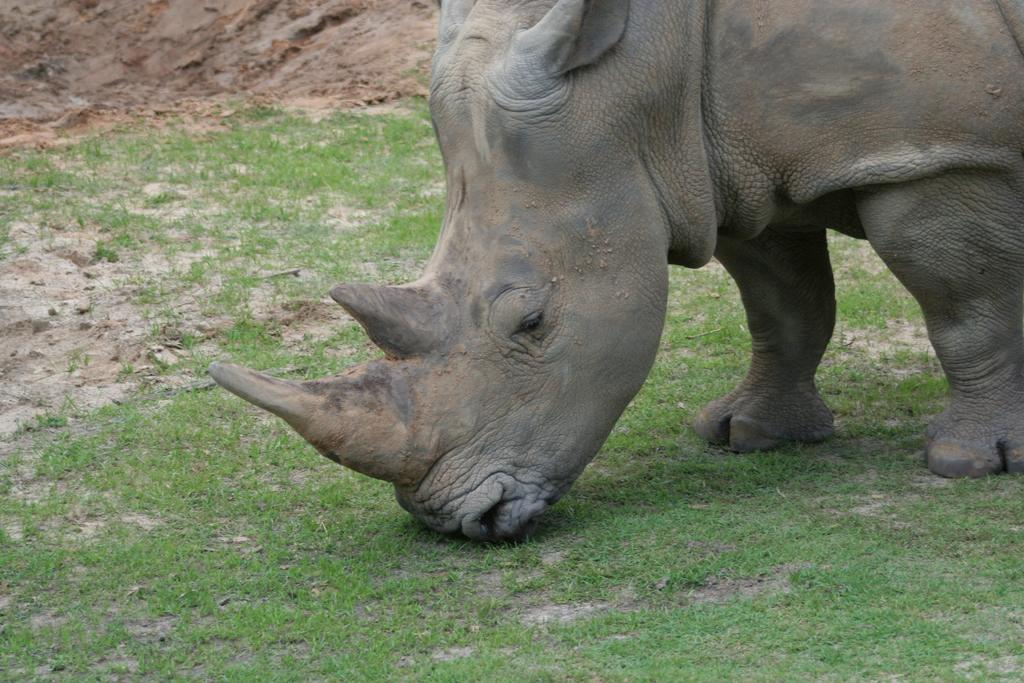What animal is present in the image? There is a rhinoceros in the image. What type of terrain is visible in the image? There is grass on the ground in the image. What type of quill is the rhinoceros using to write a message? There is no quill present in the image, and the rhinoceros is not writing a message. 